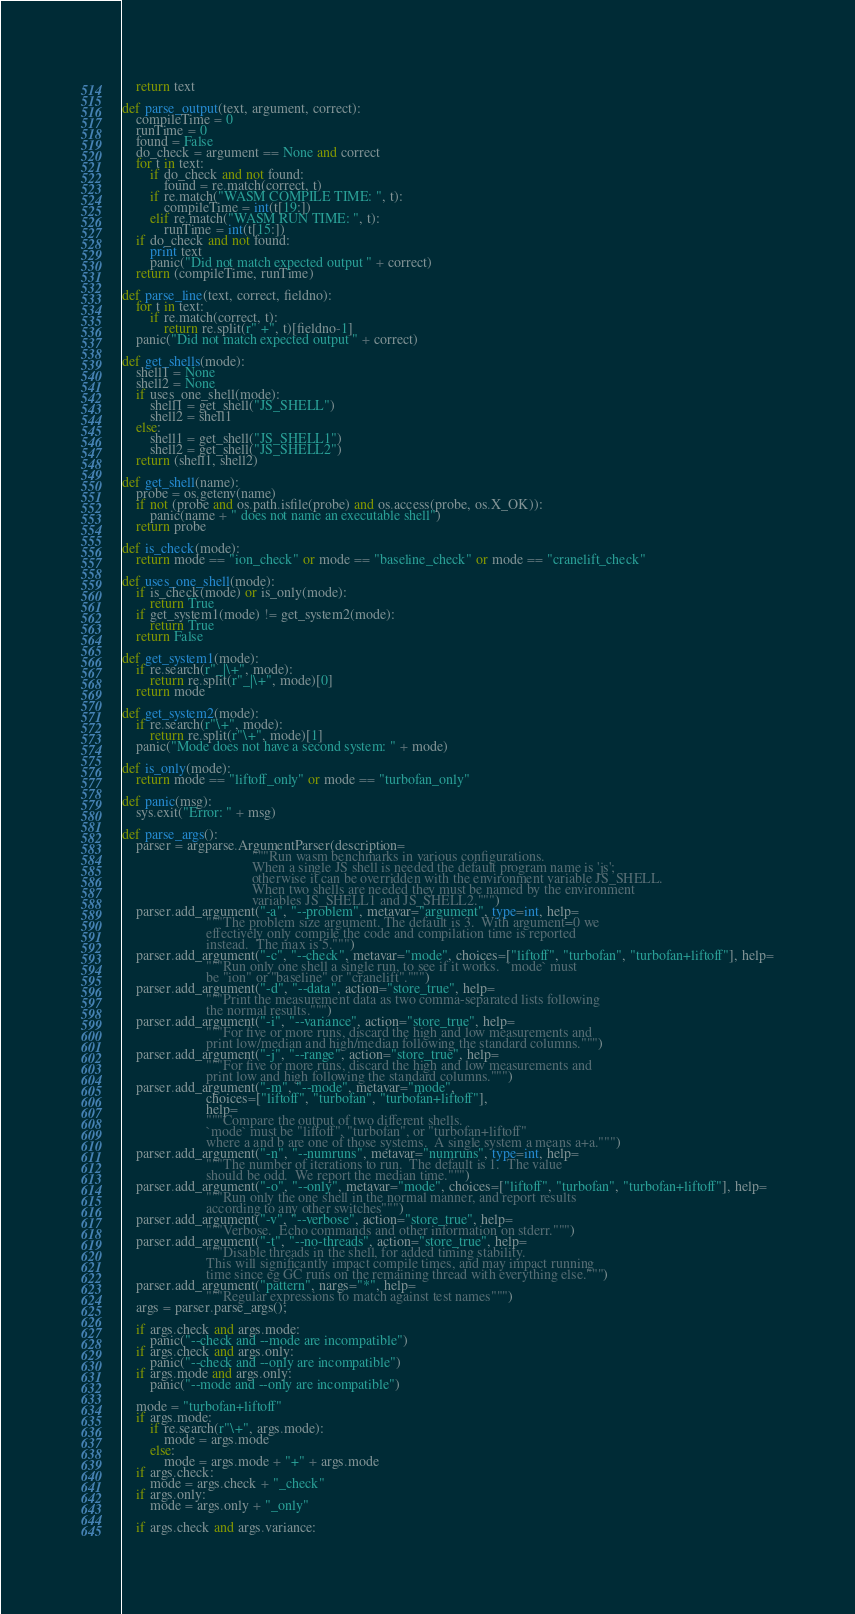<code> <loc_0><loc_0><loc_500><loc_500><_Python_>    return text

def parse_output(text, argument, correct):
    compileTime = 0
    runTime = 0
    found = False
    do_check = argument == None and correct
    for t in text:
        if do_check and not found:
            found = re.match(correct, t)
        if re.match("WASM COMPILE TIME: ", t):
            compileTime = int(t[19:])
        elif re.match("WASM RUN TIME: ", t):
            runTime = int(t[15:])
    if do_check and not found:
        print text
        panic("Did not match expected output " + correct)
    return (compileTime, runTime)

def parse_line(text, correct, fieldno):
    for t in text:
        if re.match(correct, t):
            return re.split(r" +", t)[fieldno-1]
    panic("Did not match expected output " + correct)

def get_shells(mode):
    shell1 = None
    shell2 = None
    if uses_one_shell(mode):
        shell1 = get_shell("JS_SHELL")
        shell2 = shell1
    else:
        shell1 = get_shell("JS_SHELL1")
        shell2 = get_shell("JS_SHELL2")
    return (shell1, shell2)

def get_shell(name):
    probe = os.getenv(name)
    if not (probe and os.path.isfile(probe) and os.access(probe, os.X_OK)):
        panic(name + " does not name an executable shell")
    return probe

def is_check(mode):
    return mode == "ion_check" or mode == "baseline_check" or mode == "cranelift_check"

def uses_one_shell(mode):
    if is_check(mode) or is_only(mode):
        return True
    if get_system1(mode) != get_system2(mode):
        return True
    return False
 
def get_system1(mode):
    if re.search(r"_|\+", mode):
        return re.split(r"_|\+", mode)[0]
    return mode

def get_system2(mode):
    if re.search(r"\+", mode):
        return re.split(r"\+", mode)[1]
    panic("Mode does not have a second system: " + mode)

def is_only(mode):
    return mode == "liftoff_only" or mode == "turbofan_only"

def panic(msg):
    sys.exit("Error: " + msg)

def parse_args():
    parser = argparse.ArgumentParser(description=
                                     """Run wasm benchmarks in various configurations.
                                     When a single JS shell is needed the default program name is 'js'; 
                                     otherwise it can be overridden with the environment variable JS_SHELL.
                                     When two shells are needed they must be named by the environment
                                     variables JS_SHELL1 and JS_SHELL2.""")
    parser.add_argument("-a", "--problem", metavar="argument", type=int, help=
                        """The problem size argument. The default is 3.  With argument=0 we
                        effectively only compile the code and compilation time is reported
                        instead.  The max is 5.""")
    parser.add_argument("-c", "--check", metavar="mode", choices=["liftoff", "turbofan", "turbofan+liftoff"], help=
                        """Run only one shell a single run, to see if it works.  `mode` must
                        be "ion" or "baseline" or "cranelift".""")
    parser.add_argument("-d", "--data", action="store_true", help=
                        """Print the measurement data as two comma-separated lists following
                        the normal results.""")
    parser.add_argument("-i", "--variance", action="store_true", help=
                        """For five or more runs, discard the high and low measurements and
                        print low/median and high/median following the standard columns.""")
    parser.add_argument("-j", "--range", action="store_true", help=
                        """For five or more runs, discard the high and low measurements and
                        print low and high following the standard columns.""")
    parser.add_argument("-m", "--mode", metavar="mode",
                        choices=["liftoff", "turbofan", "turbofan+liftoff"],
                        help=
                        """Compare the output of two different shells.  
                        `mode` must be "liftoff", "turbofan", or "turbofan+liftoff" 
                        where a and b are one of those systems.  A single system a means a+a.""")
    parser.add_argument("-n", "--numruns", metavar="numruns", type=int, help=
                        """The number of iterations to run.  The default is 1.  The value
                        should be odd.  We report the median time.""")
    parser.add_argument("-o", "--only", metavar="mode", choices=["liftoff", "turbofan", "turbofan+liftoff"], help=
                        """Run only the one shell in the normal manner, and report results
                        according to any other switches""")
    parser.add_argument("-v", "--verbose", action="store_true", help=
                        """Verbose.  Echo commands and other information on stderr.""")
    parser.add_argument("-t", "--no-threads", action="store_true", help=
                        """Disable threads in the shell, for added timing stability.
                        This will significantly impact compile times, and may impact running
                        time since eg GC runs on the remaining thread with everything else.""")
    parser.add_argument("pattern", nargs="*", help=
                        """Regular expressions to match against test names""")
    args = parser.parse_args();

    if args.check and args.mode:
        panic("--check and --mode are incompatible")
    if args.check and args.only:
        panic("--check and --only are incompatible")
    if args.mode and args.only:
        panic("--mode and --only are incompatible")

    mode = "turbofan+liftoff"
    if args.mode:
        if re.search(r"\+", args.mode):
            mode = args.mode
        else:
            mode = args.mode + "+" + args.mode
    if args.check:
        mode = args.check + "_check"
    if args.only:
        mode = args.only + "_only"

    if args.check and args.variance:</code> 